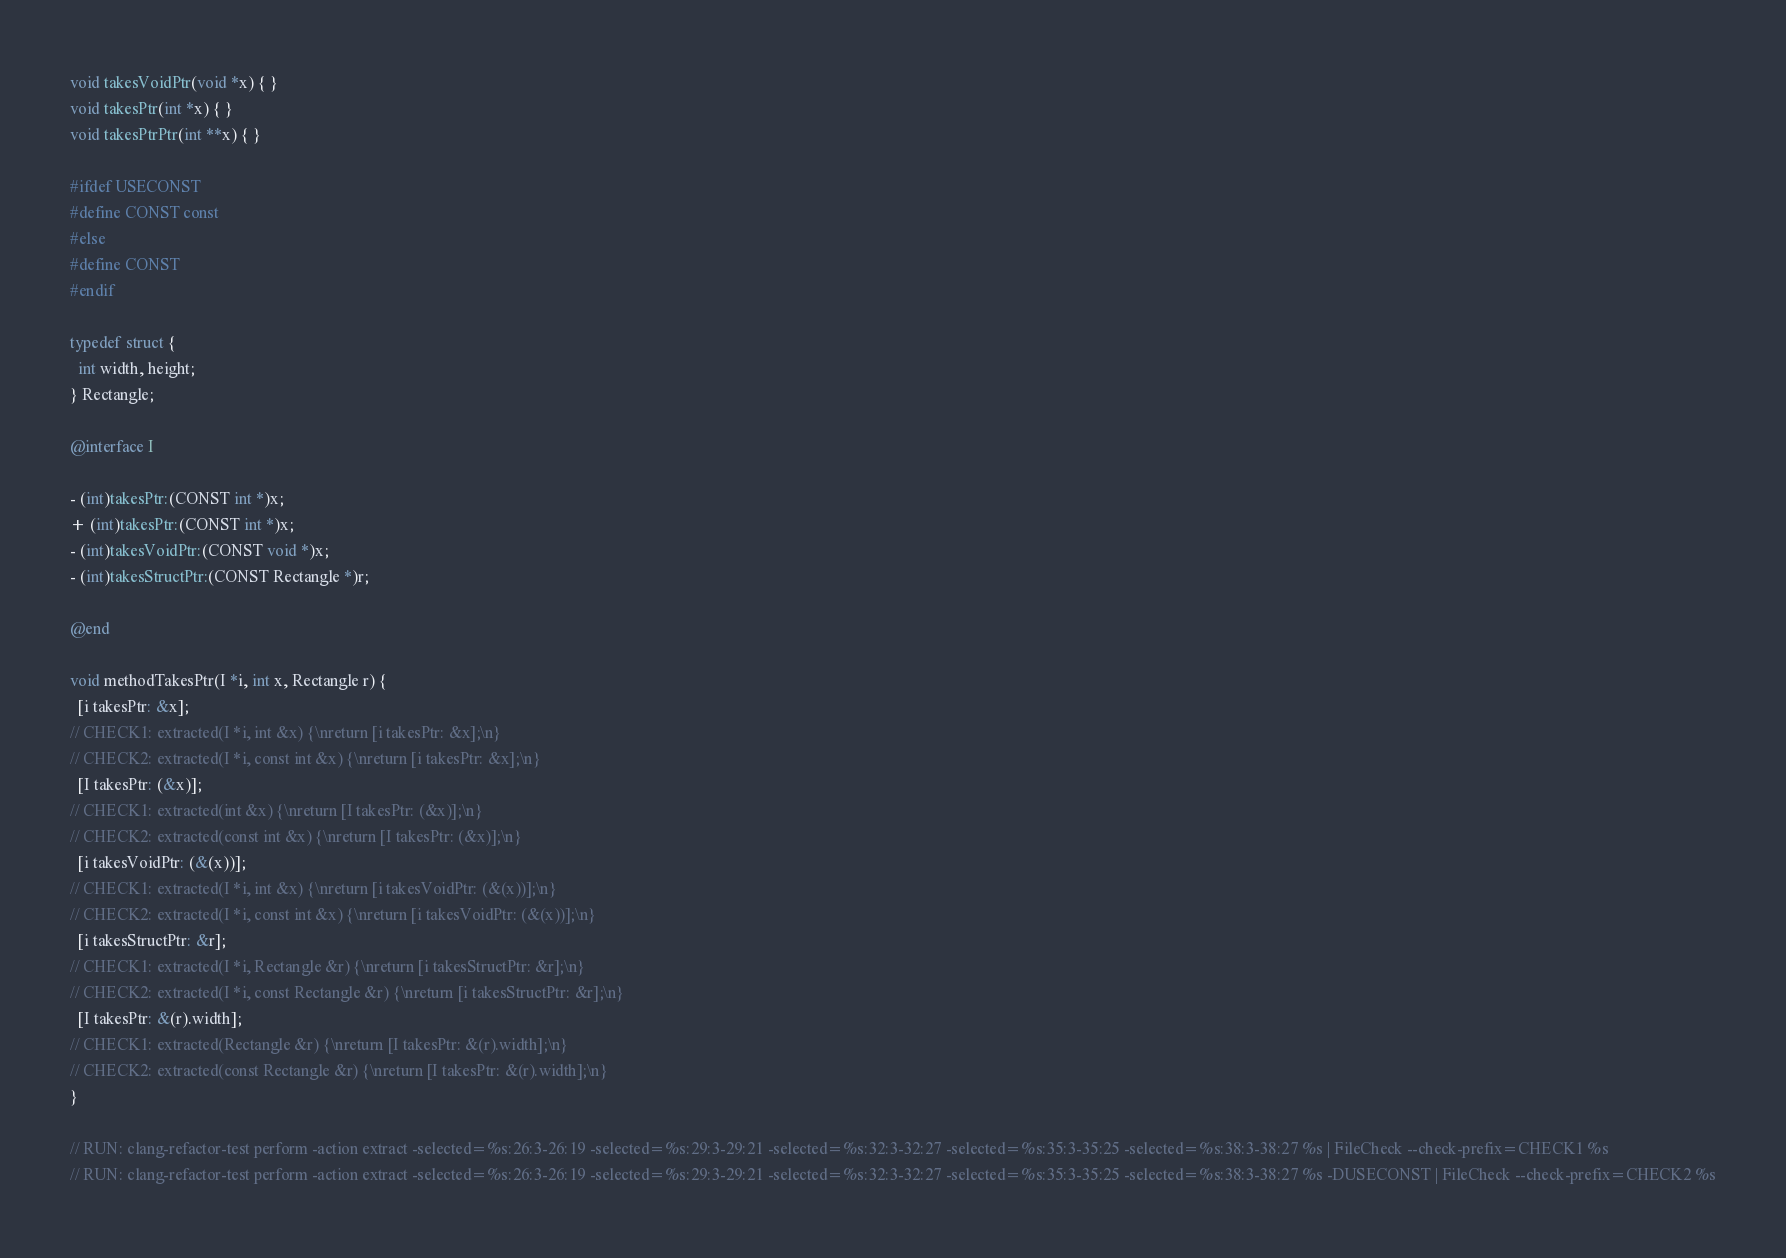<code> <loc_0><loc_0><loc_500><loc_500><_ObjectiveC_>
void takesVoidPtr(void *x) { }
void takesPtr(int *x) { }
void takesPtrPtr(int **x) { }

#ifdef USECONST
#define CONST const
#else
#define CONST
#endif

typedef struct {
  int width, height;
} Rectangle;

@interface I

- (int)takesPtr:(CONST int *)x;
+ (int)takesPtr:(CONST int *)x;
- (int)takesVoidPtr:(CONST void *)x;
- (int)takesStructPtr:(CONST Rectangle *)r;

@end

void methodTakesPtr(I *i, int x, Rectangle r) {
  [i takesPtr: &x];
// CHECK1: extracted(I *i, int &x) {\nreturn [i takesPtr: &x];\n}
// CHECK2: extracted(I *i, const int &x) {\nreturn [i takesPtr: &x];\n}
  [I takesPtr: (&x)];
// CHECK1: extracted(int &x) {\nreturn [I takesPtr: (&x)];\n}
// CHECK2: extracted(const int &x) {\nreturn [I takesPtr: (&x)];\n}
  [i takesVoidPtr: (&(x))];
// CHECK1: extracted(I *i, int &x) {\nreturn [i takesVoidPtr: (&(x))];\n}
// CHECK2: extracted(I *i, const int &x) {\nreturn [i takesVoidPtr: (&(x))];\n}
  [i takesStructPtr: &r];
// CHECK1: extracted(I *i, Rectangle &r) {\nreturn [i takesStructPtr: &r];\n}
// CHECK2: extracted(I *i, const Rectangle &r) {\nreturn [i takesStructPtr: &r];\n}
  [I takesPtr: &(r).width];
// CHECK1: extracted(Rectangle &r) {\nreturn [I takesPtr: &(r).width];\n}
// CHECK2: extracted(const Rectangle &r) {\nreturn [I takesPtr: &(r).width];\n}
}

// RUN: clang-refactor-test perform -action extract -selected=%s:26:3-26:19 -selected=%s:29:3-29:21 -selected=%s:32:3-32:27 -selected=%s:35:3-35:25 -selected=%s:38:3-38:27 %s | FileCheck --check-prefix=CHECK1 %s
// RUN: clang-refactor-test perform -action extract -selected=%s:26:3-26:19 -selected=%s:29:3-29:21 -selected=%s:32:3-32:27 -selected=%s:35:3-35:25 -selected=%s:38:3-38:27 %s -DUSECONST | FileCheck --check-prefix=CHECK2 %s
</code> 